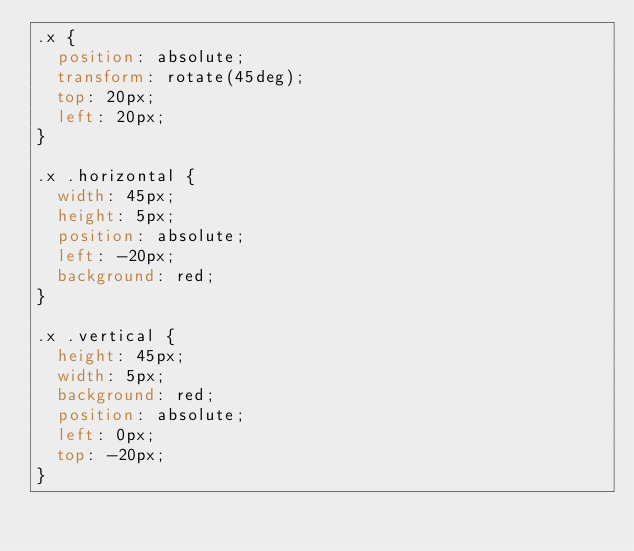Convert code to text. <code><loc_0><loc_0><loc_500><loc_500><_CSS_>.x {
  position: absolute;
  transform: rotate(45deg);
  top: 20px;
  left: 20px;
}

.x .horizontal {
  width: 45px;
  height: 5px;
  position: absolute;
  left: -20px;
  background: red;
}

.x .vertical {
  height: 45px;
  width: 5px;
  background: red;
  position: absolute;
  left: 0px;
  top: -20px;
}
</code> 